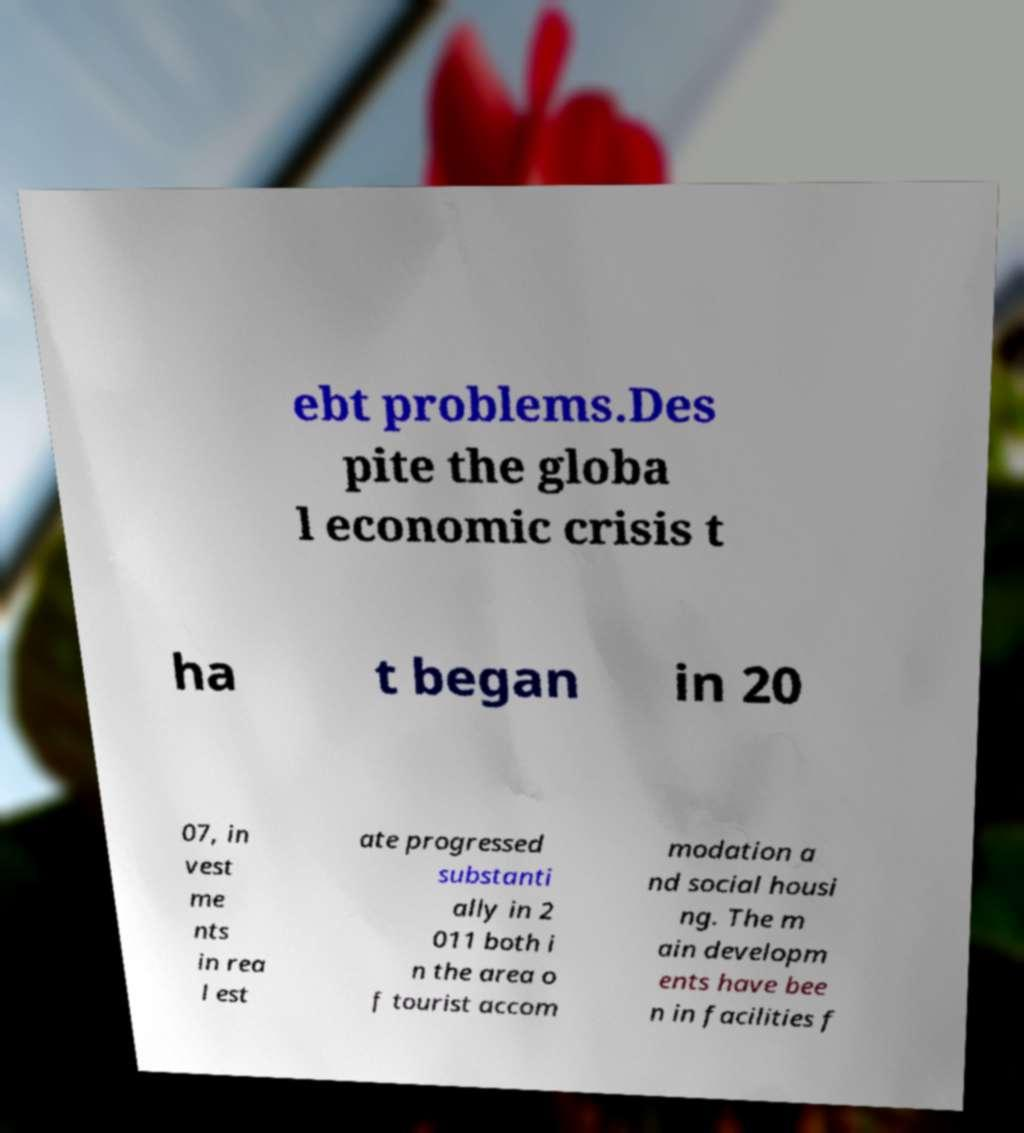Could you extract and type out the text from this image? ebt problems.Des pite the globa l economic crisis t ha t began in 20 07, in vest me nts in rea l est ate progressed substanti ally in 2 011 both i n the area o f tourist accom modation a nd social housi ng. The m ain developm ents have bee n in facilities f 